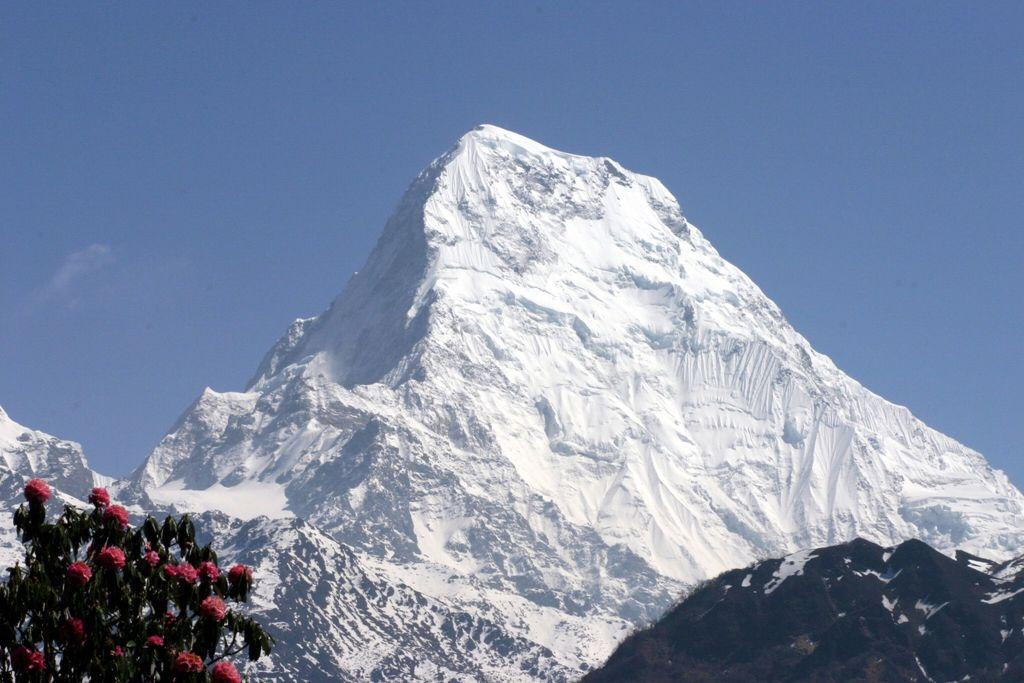What can be found in the bottom left corner of the image? There are flowers and leaves in the bottom left of the image. What type of natural formation is visible in the image? There are mountains in the image. How are the mountains depicted? The mountains are covered with snow. What color is the sky in the image? The sky is blue in color. What language is being spoken by the kitty in the image? There is no kitty present in the image, and therefore no language being spoken. Where is the bucket located in the image? There is no bucket present in the image. 